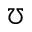<formula> <loc_0><loc_0><loc_500><loc_500>\mho</formula> 